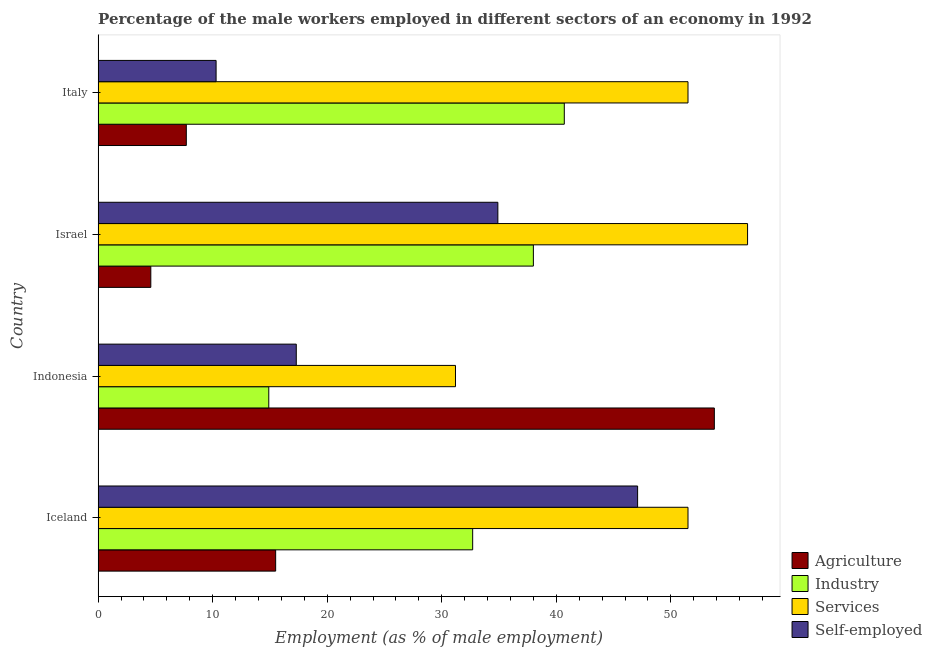How many groups of bars are there?
Your answer should be very brief. 4. Are the number of bars per tick equal to the number of legend labels?
Provide a short and direct response. Yes. How many bars are there on the 1st tick from the top?
Your answer should be very brief. 4. How many bars are there on the 3rd tick from the bottom?
Give a very brief answer. 4. What is the label of the 2nd group of bars from the top?
Provide a short and direct response. Israel. In how many cases, is the number of bars for a given country not equal to the number of legend labels?
Provide a succinct answer. 0. What is the percentage of self employed male workers in Israel?
Keep it short and to the point. 34.9. Across all countries, what is the maximum percentage of male workers in industry?
Ensure brevity in your answer.  40.7. Across all countries, what is the minimum percentage of self employed male workers?
Offer a terse response. 10.3. In which country was the percentage of self employed male workers minimum?
Give a very brief answer. Italy. What is the total percentage of male workers in services in the graph?
Keep it short and to the point. 190.9. What is the difference between the percentage of male workers in agriculture in Indonesia and that in Italy?
Provide a succinct answer. 46.1. What is the difference between the percentage of self employed male workers in Israel and the percentage of male workers in industry in Indonesia?
Offer a very short reply. 20. What is the average percentage of self employed male workers per country?
Provide a short and direct response. 27.4. What is the difference between the percentage of male workers in industry and percentage of self employed male workers in Iceland?
Your answer should be very brief. -14.4. In how many countries, is the percentage of self employed male workers greater than 46 %?
Your answer should be compact. 1. What is the ratio of the percentage of male workers in agriculture in Iceland to that in Israel?
Provide a short and direct response. 3.37. Is the percentage of male workers in agriculture in Iceland less than that in Italy?
Provide a short and direct response. No. What is the difference between the highest and the second highest percentage of male workers in agriculture?
Offer a very short reply. 38.3. What is the difference between the highest and the lowest percentage of male workers in agriculture?
Provide a succinct answer. 49.2. Is the sum of the percentage of male workers in agriculture in Israel and Italy greater than the maximum percentage of male workers in industry across all countries?
Make the answer very short. No. Is it the case that in every country, the sum of the percentage of male workers in agriculture and percentage of male workers in services is greater than the sum of percentage of male workers in industry and percentage of self employed male workers?
Make the answer very short. No. What does the 3rd bar from the top in Iceland represents?
Provide a short and direct response. Industry. What does the 2nd bar from the bottom in Italy represents?
Your response must be concise. Industry. Is it the case that in every country, the sum of the percentage of male workers in agriculture and percentage of male workers in industry is greater than the percentage of male workers in services?
Offer a very short reply. No. Are the values on the major ticks of X-axis written in scientific E-notation?
Your answer should be very brief. No. Does the graph contain any zero values?
Provide a short and direct response. No. What is the title of the graph?
Keep it short and to the point. Percentage of the male workers employed in different sectors of an economy in 1992. What is the label or title of the X-axis?
Your answer should be compact. Employment (as % of male employment). What is the Employment (as % of male employment) in Agriculture in Iceland?
Provide a short and direct response. 15.5. What is the Employment (as % of male employment) of Industry in Iceland?
Your response must be concise. 32.7. What is the Employment (as % of male employment) of Services in Iceland?
Offer a terse response. 51.5. What is the Employment (as % of male employment) in Self-employed in Iceland?
Make the answer very short. 47.1. What is the Employment (as % of male employment) in Agriculture in Indonesia?
Provide a succinct answer. 53.8. What is the Employment (as % of male employment) in Industry in Indonesia?
Your answer should be compact. 14.9. What is the Employment (as % of male employment) of Services in Indonesia?
Your answer should be compact. 31.2. What is the Employment (as % of male employment) of Self-employed in Indonesia?
Offer a terse response. 17.3. What is the Employment (as % of male employment) of Agriculture in Israel?
Ensure brevity in your answer.  4.6. What is the Employment (as % of male employment) in Services in Israel?
Your answer should be compact. 56.7. What is the Employment (as % of male employment) in Self-employed in Israel?
Your answer should be very brief. 34.9. What is the Employment (as % of male employment) of Agriculture in Italy?
Offer a terse response. 7.7. What is the Employment (as % of male employment) in Industry in Italy?
Provide a succinct answer. 40.7. What is the Employment (as % of male employment) of Services in Italy?
Make the answer very short. 51.5. What is the Employment (as % of male employment) in Self-employed in Italy?
Keep it short and to the point. 10.3. Across all countries, what is the maximum Employment (as % of male employment) in Agriculture?
Keep it short and to the point. 53.8. Across all countries, what is the maximum Employment (as % of male employment) of Industry?
Ensure brevity in your answer.  40.7. Across all countries, what is the maximum Employment (as % of male employment) in Services?
Make the answer very short. 56.7. Across all countries, what is the maximum Employment (as % of male employment) of Self-employed?
Ensure brevity in your answer.  47.1. Across all countries, what is the minimum Employment (as % of male employment) in Agriculture?
Make the answer very short. 4.6. Across all countries, what is the minimum Employment (as % of male employment) of Industry?
Your response must be concise. 14.9. Across all countries, what is the minimum Employment (as % of male employment) of Services?
Make the answer very short. 31.2. Across all countries, what is the minimum Employment (as % of male employment) of Self-employed?
Provide a short and direct response. 10.3. What is the total Employment (as % of male employment) of Agriculture in the graph?
Provide a short and direct response. 81.6. What is the total Employment (as % of male employment) of Industry in the graph?
Offer a very short reply. 126.3. What is the total Employment (as % of male employment) in Services in the graph?
Provide a succinct answer. 190.9. What is the total Employment (as % of male employment) in Self-employed in the graph?
Ensure brevity in your answer.  109.6. What is the difference between the Employment (as % of male employment) of Agriculture in Iceland and that in Indonesia?
Keep it short and to the point. -38.3. What is the difference between the Employment (as % of male employment) in Services in Iceland and that in Indonesia?
Provide a short and direct response. 20.3. What is the difference between the Employment (as % of male employment) in Self-employed in Iceland and that in Indonesia?
Your response must be concise. 29.8. What is the difference between the Employment (as % of male employment) in Agriculture in Iceland and that in Israel?
Give a very brief answer. 10.9. What is the difference between the Employment (as % of male employment) in Industry in Iceland and that in Israel?
Offer a very short reply. -5.3. What is the difference between the Employment (as % of male employment) of Self-employed in Iceland and that in Israel?
Give a very brief answer. 12.2. What is the difference between the Employment (as % of male employment) of Industry in Iceland and that in Italy?
Provide a short and direct response. -8. What is the difference between the Employment (as % of male employment) of Services in Iceland and that in Italy?
Your response must be concise. 0. What is the difference between the Employment (as % of male employment) in Self-employed in Iceland and that in Italy?
Offer a terse response. 36.8. What is the difference between the Employment (as % of male employment) in Agriculture in Indonesia and that in Israel?
Provide a succinct answer. 49.2. What is the difference between the Employment (as % of male employment) in Industry in Indonesia and that in Israel?
Keep it short and to the point. -23.1. What is the difference between the Employment (as % of male employment) of Services in Indonesia and that in Israel?
Provide a short and direct response. -25.5. What is the difference between the Employment (as % of male employment) in Self-employed in Indonesia and that in Israel?
Provide a short and direct response. -17.6. What is the difference between the Employment (as % of male employment) in Agriculture in Indonesia and that in Italy?
Provide a succinct answer. 46.1. What is the difference between the Employment (as % of male employment) of Industry in Indonesia and that in Italy?
Your answer should be compact. -25.8. What is the difference between the Employment (as % of male employment) in Services in Indonesia and that in Italy?
Offer a very short reply. -20.3. What is the difference between the Employment (as % of male employment) in Self-employed in Indonesia and that in Italy?
Your response must be concise. 7. What is the difference between the Employment (as % of male employment) of Agriculture in Israel and that in Italy?
Your answer should be compact. -3.1. What is the difference between the Employment (as % of male employment) in Industry in Israel and that in Italy?
Ensure brevity in your answer.  -2.7. What is the difference between the Employment (as % of male employment) in Services in Israel and that in Italy?
Offer a very short reply. 5.2. What is the difference between the Employment (as % of male employment) of Self-employed in Israel and that in Italy?
Your answer should be very brief. 24.6. What is the difference between the Employment (as % of male employment) of Agriculture in Iceland and the Employment (as % of male employment) of Services in Indonesia?
Ensure brevity in your answer.  -15.7. What is the difference between the Employment (as % of male employment) of Industry in Iceland and the Employment (as % of male employment) of Services in Indonesia?
Your answer should be compact. 1.5. What is the difference between the Employment (as % of male employment) in Services in Iceland and the Employment (as % of male employment) in Self-employed in Indonesia?
Give a very brief answer. 34.2. What is the difference between the Employment (as % of male employment) in Agriculture in Iceland and the Employment (as % of male employment) in Industry in Israel?
Your answer should be very brief. -22.5. What is the difference between the Employment (as % of male employment) in Agriculture in Iceland and the Employment (as % of male employment) in Services in Israel?
Provide a short and direct response. -41.2. What is the difference between the Employment (as % of male employment) of Agriculture in Iceland and the Employment (as % of male employment) of Self-employed in Israel?
Your response must be concise. -19.4. What is the difference between the Employment (as % of male employment) of Industry in Iceland and the Employment (as % of male employment) of Self-employed in Israel?
Offer a terse response. -2.2. What is the difference between the Employment (as % of male employment) of Agriculture in Iceland and the Employment (as % of male employment) of Industry in Italy?
Ensure brevity in your answer.  -25.2. What is the difference between the Employment (as % of male employment) of Agriculture in Iceland and the Employment (as % of male employment) of Services in Italy?
Make the answer very short. -36. What is the difference between the Employment (as % of male employment) in Industry in Iceland and the Employment (as % of male employment) in Services in Italy?
Ensure brevity in your answer.  -18.8. What is the difference between the Employment (as % of male employment) in Industry in Iceland and the Employment (as % of male employment) in Self-employed in Italy?
Your answer should be very brief. 22.4. What is the difference between the Employment (as % of male employment) of Services in Iceland and the Employment (as % of male employment) of Self-employed in Italy?
Your answer should be compact. 41.2. What is the difference between the Employment (as % of male employment) in Agriculture in Indonesia and the Employment (as % of male employment) in Industry in Israel?
Provide a short and direct response. 15.8. What is the difference between the Employment (as % of male employment) in Agriculture in Indonesia and the Employment (as % of male employment) in Self-employed in Israel?
Make the answer very short. 18.9. What is the difference between the Employment (as % of male employment) of Industry in Indonesia and the Employment (as % of male employment) of Services in Israel?
Offer a very short reply. -41.8. What is the difference between the Employment (as % of male employment) of Agriculture in Indonesia and the Employment (as % of male employment) of Industry in Italy?
Offer a very short reply. 13.1. What is the difference between the Employment (as % of male employment) in Agriculture in Indonesia and the Employment (as % of male employment) in Self-employed in Italy?
Your response must be concise. 43.5. What is the difference between the Employment (as % of male employment) in Industry in Indonesia and the Employment (as % of male employment) in Services in Italy?
Make the answer very short. -36.6. What is the difference between the Employment (as % of male employment) in Services in Indonesia and the Employment (as % of male employment) in Self-employed in Italy?
Your answer should be very brief. 20.9. What is the difference between the Employment (as % of male employment) in Agriculture in Israel and the Employment (as % of male employment) in Industry in Italy?
Provide a short and direct response. -36.1. What is the difference between the Employment (as % of male employment) in Agriculture in Israel and the Employment (as % of male employment) in Services in Italy?
Your response must be concise. -46.9. What is the difference between the Employment (as % of male employment) of Industry in Israel and the Employment (as % of male employment) of Self-employed in Italy?
Your answer should be very brief. 27.7. What is the difference between the Employment (as % of male employment) in Services in Israel and the Employment (as % of male employment) in Self-employed in Italy?
Offer a terse response. 46.4. What is the average Employment (as % of male employment) in Agriculture per country?
Your answer should be very brief. 20.4. What is the average Employment (as % of male employment) in Industry per country?
Give a very brief answer. 31.57. What is the average Employment (as % of male employment) in Services per country?
Provide a succinct answer. 47.73. What is the average Employment (as % of male employment) in Self-employed per country?
Your answer should be compact. 27.4. What is the difference between the Employment (as % of male employment) of Agriculture and Employment (as % of male employment) of Industry in Iceland?
Offer a very short reply. -17.2. What is the difference between the Employment (as % of male employment) in Agriculture and Employment (as % of male employment) in Services in Iceland?
Your answer should be compact. -36. What is the difference between the Employment (as % of male employment) in Agriculture and Employment (as % of male employment) in Self-employed in Iceland?
Your answer should be very brief. -31.6. What is the difference between the Employment (as % of male employment) in Industry and Employment (as % of male employment) in Services in Iceland?
Your answer should be very brief. -18.8. What is the difference between the Employment (as % of male employment) of Industry and Employment (as % of male employment) of Self-employed in Iceland?
Keep it short and to the point. -14.4. What is the difference between the Employment (as % of male employment) of Agriculture and Employment (as % of male employment) of Industry in Indonesia?
Offer a very short reply. 38.9. What is the difference between the Employment (as % of male employment) in Agriculture and Employment (as % of male employment) in Services in Indonesia?
Provide a succinct answer. 22.6. What is the difference between the Employment (as % of male employment) of Agriculture and Employment (as % of male employment) of Self-employed in Indonesia?
Make the answer very short. 36.5. What is the difference between the Employment (as % of male employment) in Industry and Employment (as % of male employment) in Services in Indonesia?
Offer a very short reply. -16.3. What is the difference between the Employment (as % of male employment) of Industry and Employment (as % of male employment) of Self-employed in Indonesia?
Ensure brevity in your answer.  -2.4. What is the difference between the Employment (as % of male employment) in Services and Employment (as % of male employment) in Self-employed in Indonesia?
Provide a succinct answer. 13.9. What is the difference between the Employment (as % of male employment) in Agriculture and Employment (as % of male employment) in Industry in Israel?
Offer a terse response. -33.4. What is the difference between the Employment (as % of male employment) in Agriculture and Employment (as % of male employment) in Services in Israel?
Offer a terse response. -52.1. What is the difference between the Employment (as % of male employment) of Agriculture and Employment (as % of male employment) of Self-employed in Israel?
Keep it short and to the point. -30.3. What is the difference between the Employment (as % of male employment) in Industry and Employment (as % of male employment) in Services in Israel?
Keep it short and to the point. -18.7. What is the difference between the Employment (as % of male employment) of Industry and Employment (as % of male employment) of Self-employed in Israel?
Your answer should be compact. 3.1. What is the difference between the Employment (as % of male employment) of Services and Employment (as % of male employment) of Self-employed in Israel?
Provide a short and direct response. 21.8. What is the difference between the Employment (as % of male employment) of Agriculture and Employment (as % of male employment) of Industry in Italy?
Provide a succinct answer. -33. What is the difference between the Employment (as % of male employment) of Agriculture and Employment (as % of male employment) of Services in Italy?
Make the answer very short. -43.8. What is the difference between the Employment (as % of male employment) in Agriculture and Employment (as % of male employment) in Self-employed in Italy?
Your response must be concise. -2.6. What is the difference between the Employment (as % of male employment) of Industry and Employment (as % of male employment) of Services in Italy?
Provide a succinct answer. -10.8. What is the difference between the Employment (as % of male employment) in Industry and Employment (as % of male employment) in Self-employed in Italy?
Make the answer very short. 30.4. What is the difference between the Employment (as % of male employment) of Services and Employment (as % of male employment) of Self-employed in Italy?
Keep it short and to the point. 41.2. What is the ratio of the Employment (as % of male employment) of Agriculture in Iceland to that in Indonesia?
Your answer should be compact. 0.29. What is the ratio of the Employment (as % of male employment) in Industry in Iceland to that in Indonesia?
Your answer should be very brief. 2.19. What is the ratio of the Employment (as % of male employment) in Services in Iceland to that in Indonesia?
Your response must be concise. 1.65. What is the ratio of the Employment (as % of male employment) of Self-employed in Iceland to that in Indonesia?
Your answer should be compact. 2.72. What is the ratio of the Employment (as % of male employment) in Agriculture in Iceland to that in Israel?
Ensure brevity in your answer.  3.37. What is the ratio of the Employment (as % of male employment) of Industry in Iceland to that in Israel?
Offer a very short reply. 0.86. What is the ratio of the Employment (as % of male employment) in Services in Iceland to that in Israel?
Provide a succinct answer. 0.91. What is the ratio of the Employment (as % of male employment) of Self-employed in Iceland to that in Israel?
Provide a short and direct response. 1.35. What is the ratio of the Employment (as % of male employment) in Agriculture in Iceland to that in Italy?
Offer a terse response. 2.01. What is the ratio of the Employment (as % of male employment) in Industry in Iceland to that in Italy?
Offer a very short reply. 0.8. What is the ratio of the Employment (as % of male employment) in Services in Iceland to that in Italy?
Keep it short and to the point. 1. What is the ratio of the Employment (as % of male employment) in Self-employed in Iceland to that in Italy?
Ensure brevity in your answer.  4.57. What is the ratio of the Employment (as % of male employment) of Agriculture in Indonesia to that in Israel?
Make the answer very short. 11.7. What is the ratio of the Employment (as % of male employment) of Industry in Indonesia to that in Israel?
Your response must be concise. 0.39. What is the ratio of the Employment (as % of male employment) of Services in Indonesia to that in Israel?
Keep it short and to the point. 0.55. What is the ratio of the Employment (as % of male employment) of Self-employed in Indonesia to that in Israel?
Your response must be concise. 0.5. What is the ratio of the Employment (as % of male employment) in Agriculture in Indonesia to that in Italy?
Offer a terse response. 6.99. What is the ratio of the Employment (as % of male employment) in Industry in Indonesia to that in Italy?
Keep it short and to the point. 0.37. What is the ratio of the Employment (as % of male employment) in Services in Indonesia to that in Italy?
Keep it short and to the point. 0.61. What is the ratio of the Employment (as % of male employment) in Self-employed in Indonesia to that in Italy?
Ensure brevity in your answer.  1.68. What is the ratio of the Employment (as % of male employment) in Agriculture in Israel to that in Italy?
Offer a terse response. 0.6. What is the ratio of the Employment (as % of male employment) in Industry in Israel to that in Italy?
Your response must be concise. 0.93. What is the ratio of the Employment (as % of male employment) in Services in Israel to that in Italy?
Your answer should be compact. 1.1. What is the ratio of the Employment (as % of male employment) in Self-employed in Israel to that in Italy?
Offer a terse response. 3.39. What is the difference between the highest and the second highest Employment (as % of male employment) in Agriculture?
Give a very brief answer. 38.3. What is the difference between the highest and the second highest Employment (as % of male employment) in Industry?
Provide a short and direct response. 2.7. What is the difference between the highest and the second highest Employment (as % of male employment) in Self-employed?
Offer a very short reply. 12.2. What is the difference between the highest and the lowest Employment (as % of male employment) of Agriculture?
Your response must be concise. 49.2. What is the difference between the highest and the lowest Employment (as % of male employment) of Industry?
Your answer should be very brief. 25.8. What is the difference between the highest and the lowest Employment (as % of male employment) in Self-employed?
Offer a terse response. 36.8. 